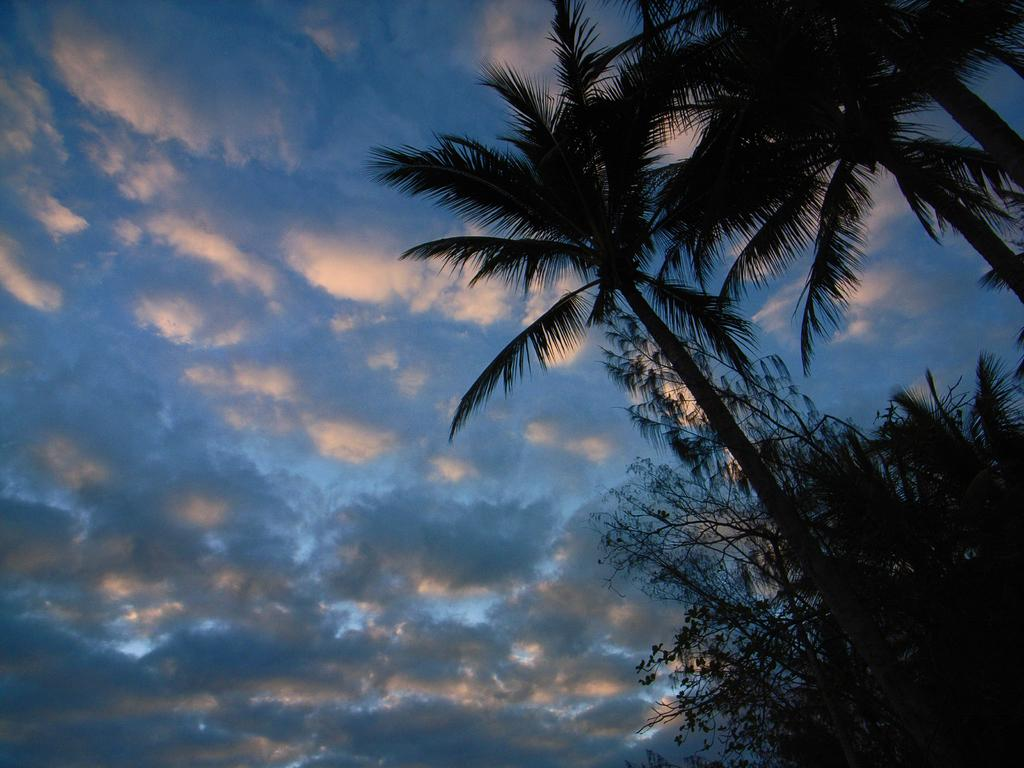What type of vegetation can be seen in the image? There are trees in the image. What part of the natural environment is visible in the image? The sky is visible in the background of the image. What type of leather is being used to make the honey in the image? There is no leather or honey present in the image; it only features trees and the sky. 